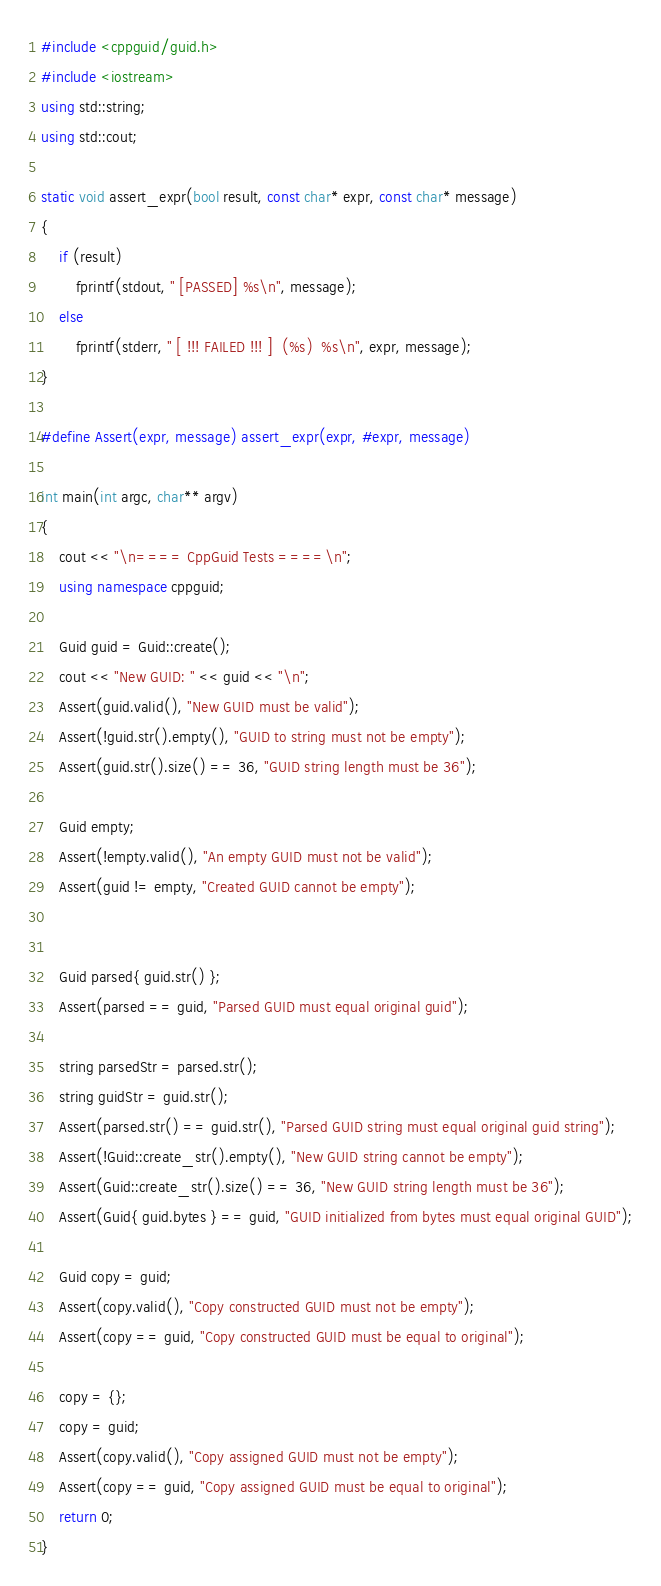Convert code to text. <code><loc_0><loc_0><loc_500><loc_500><_C++_>#include <cppguid/guid.h>
#include <iostream>
using std::string;
using std::cout;

static void assert_expr(bool result, const char* expr, const char* message)
{
    if (result)
        fprintf(stdout, " [PASSED] %s\n", message);
    else
        fprintf(stderr, " [ !!! FAILED !!! ]  (%s)  %s\n", expr, message);
}

#define Assert(expr, message) assert_expr(expr, #expr, message)

int main(int argc, char** argv)
{
    cout << "\n==== CppGuid Tests ====\n";
    using namespace cppguid;

    Guid guid = Guid::create();
    cout << "New GUID: " << guid << "\n";
    Assert(guid.valid(), "New GUID must be valid");
    Assert(!guid.str().empty(), "GUID to string must not be empty");
    Assert(guid.str().size() == 36, "GUID string length must be 36");

    Guid empty;
    Assert(!empty.valid(), "An empty GUID must not be valid");
    Assert(guid != empty, "Created GUID cannot be empty");


    Guid parsed{ guid.str() };
    Assert(parsed == guid, "Parsed GUID must equal original guid");

    string parsedStr = parsed.str();
    string guidStr = guid.str();
    Assert(parsed.str() == guid.str(), "Parsed GUID string must equal original guid string");
    Assert(!Guid::create_str().empty(), "New GUID string cannot be empty");
    Assert(Guid::create_str().size() == 36, "New GUID string length must be 36");
    Assert(Guid{ guid.bytes } == guid, "GUID initialized from bytes must equal original GUID");

    Guid copy = guid;
    Assert(copy.valid(), "Copy constructed GUID must not be empty");
    Assert(copy == guid, "Copy constructed GUID must be equal to original");

    copy = {};
    copy = guid;
    Assert(copy.valid(), "Copy assigned GUID must not be empty");
    Assert(copy == guid, "Copy assigned GUID must be equal to original");
    return 0;
}</code> 